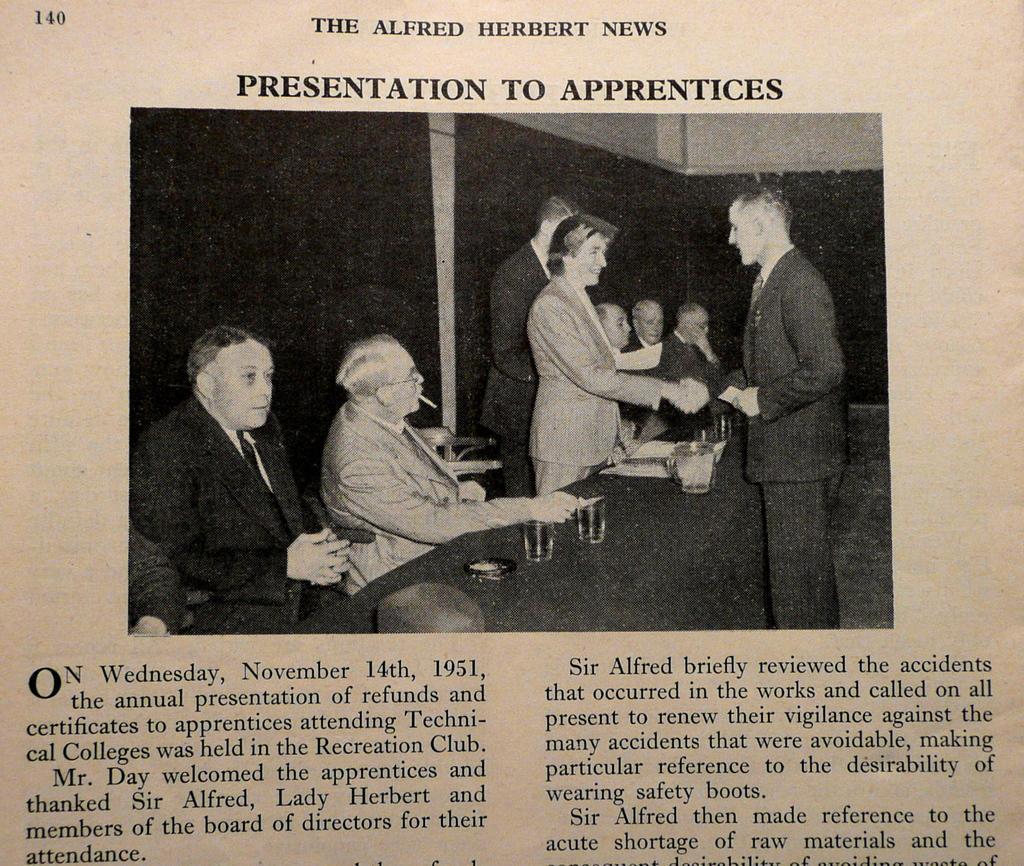Can you describe this image briefly? In this image we can see there is a paper, on which there is an image of a few people sitting and standing in front of the table, on which there are glasses, papers and some other objects. At the top and bottom of the image there is some text. 